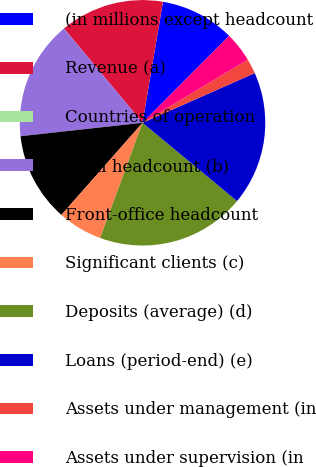Convert chart. <chart><loc_0><loc_0><loc_500><loc_500><pie_chart><fcel>(in millions except headcount<fcel>Revenue (a)<fcel>Countries of operation<fcel>Total headcount (b)<fcel>Front-office headcount<fcel>Significant clients (c)<fcel>Deposits (average) (d)<fcel>Loans (period-end) (e)<fcel>Assets under management (in<fcel>Assets under supervision (in<nl><fcel>9.8%<fcel>13.72%<fcel>0.01%<fcel>15.68%<fcel>11.76%<fcel>5.88%<fcel>19.6%<fcel>17.64%<fcel>1.97%<fcel>3.93%<nl></chart> 